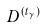<formula> <loc_0><loc_0><loc_500><loc_500>D ^ { ( t _ { \gamma } ) }</formula> 